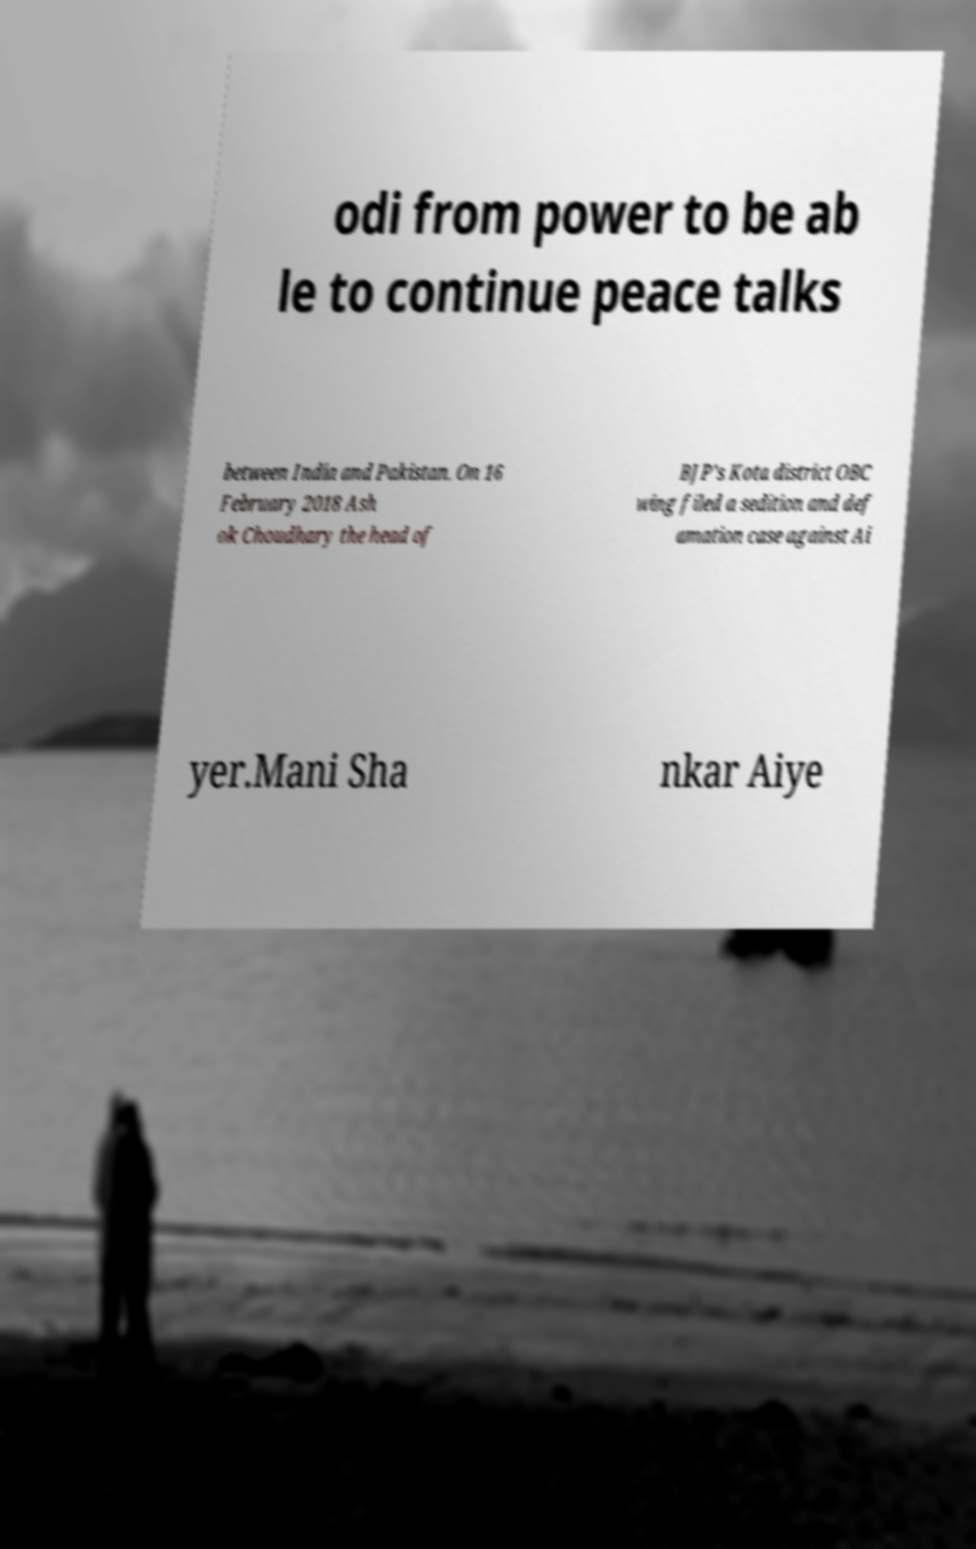Could you extract and type out the text from this image? odi from power to be ab le to continue peace talks between India and Pakistan. On 16 February 2018 Ash ok Choudhary the head of BJP's Kota district OBC wing filed a sedition and def amation case against Ai yer.Mani Sha nkar Aiye 